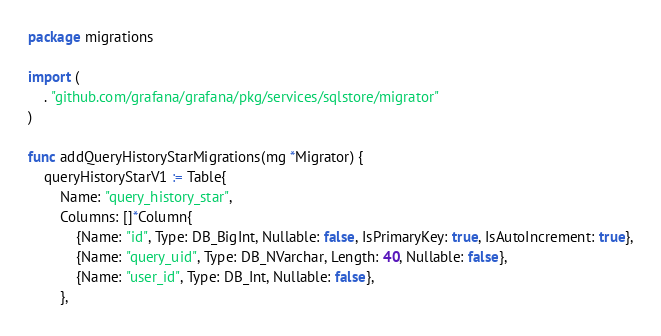<code> <loc_0><loc_0><loc_500><loc_500><_Go_>package migrations

import (
	. "github.com/grafana/grafana/pkg/services/sqlstore/migrator"
)

func addQueryHistoryStarMigrations(mg *Migrator) {
	queryHistoryStarV1 := Table{
		Name: "query_history_star",
		Columns: []*Column{
			{Name: "id", Type: DB_BigInt, Nullable: false, IsPrimaryKey: true, IsAutoIncrement: true},
			{Name: "query_uid", Type: DB_NVarchar, Length: 40, Nullable: false},
			{Name: "user_id", Type: DB_Int, Nullable: false},
		},</code> 